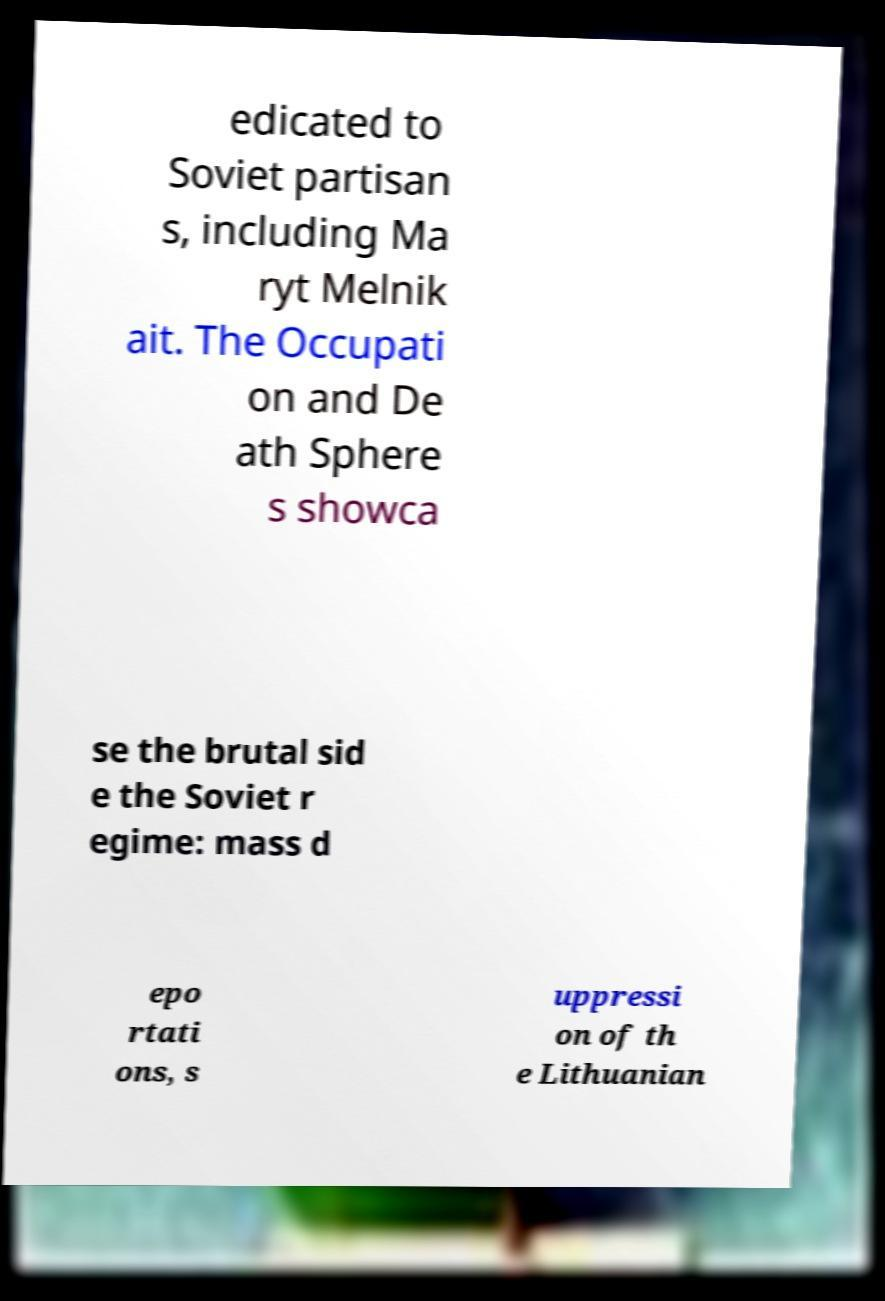There's text embedded in this image that I need extracted. Can you transcribe it verbatim? edicated to Soviet partisan s, including Ma ryt Melnik ait. The Occupati on and De ath Sphere s showca se the brutal sid e the Soviet r egime: mass d epo rtati ons, s uppressi on of th e Lithuanian 